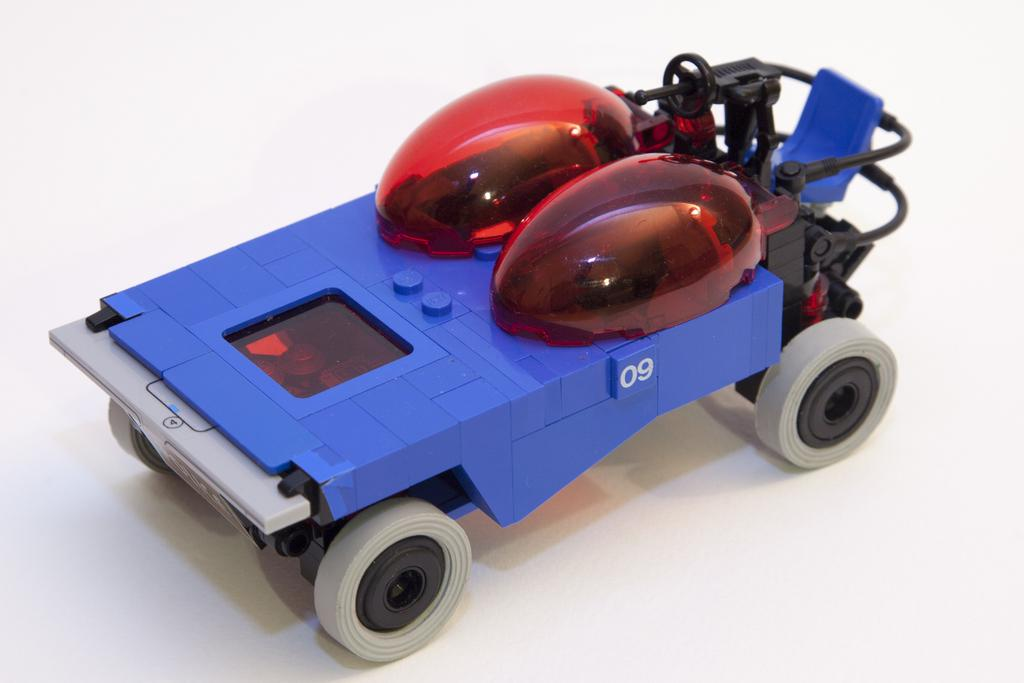What is the main object in the image? There is a toy car in the image. Where is the toy car located? The toy car is placed on a surface. Can you see a mine in the image? No, there is no mine present in the image. 